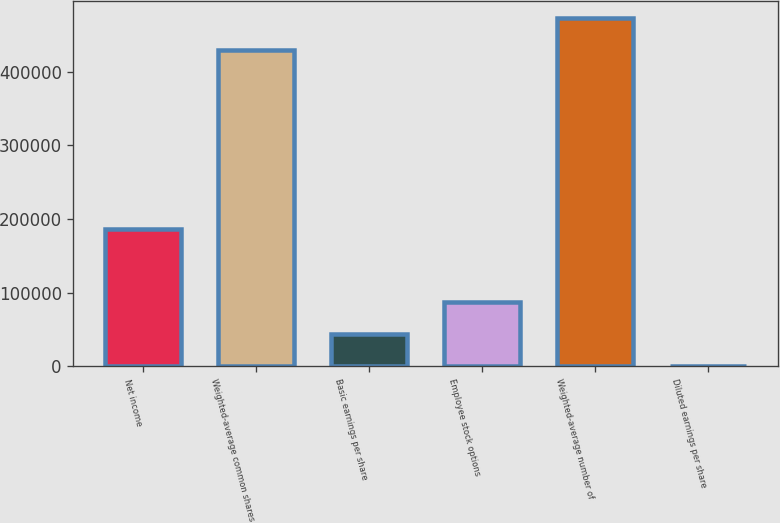<chart> <loc_0><loc_0><loc_500><loc_500><bar_chart><fcel>Net income<fcel>Weighted-average common shares<fcel>Basic earnings per share<fcel>Employee stock options<fcel>Weighted-average number of<fcel>Diluted earnings per share<nl><fcel>186678<fcel>428822<fcel>43865.6<fcel>87730.8<fcel>472687<fcel>0.43<nl></chart> 